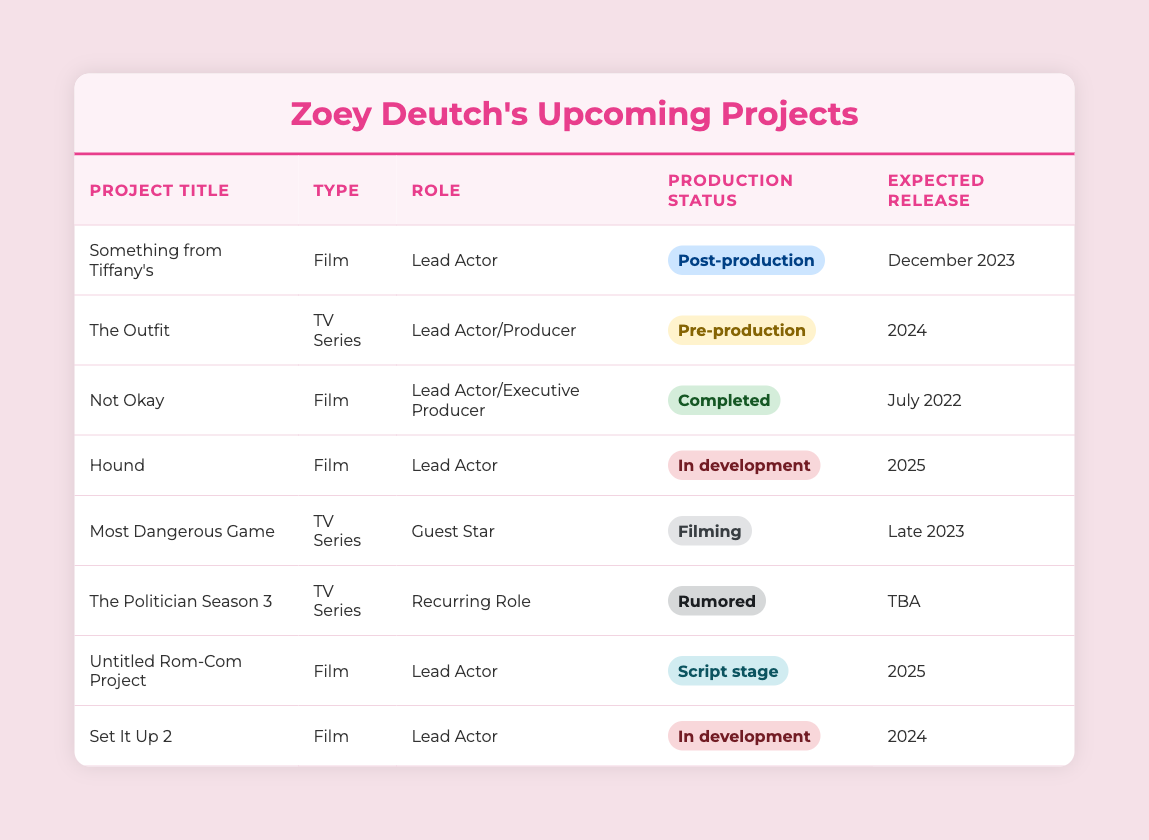What is the expected release date of "Something from Tiffany's"? The table lists the project "Something from Tiffany's" under the 'Expected Release' column, which shows "December 2023."
Answer: December 2023 How many projects are in development? The table highlights the projects "Hound" and "Set It Up 2" as being in the status of "In development." Thus, there are 2 projects in this category.
Answer: 2 Is "Not Okay" still under production? "Not Okay" is marked as "Completed" in the production status column, which means it is no longer being produced.
Answer: No What project has the status of post-production? Referring to the table, "Something from Tiffany's" is the only project with the status "Post-production."
Answer: Something from Tiffany's Which type of project has the latest expected release date? Looking at the expected release dates, "Something from Tiffany's" is scheduled for December 2023, and all other projects either have a later date or are unspecified. Therefore, this is the latest date.
Answer: Something from Tiffany's Are there more TV series projects than films upcoming from Zoey Deutch? There are four TV series (The Outfit, Most Dangerous Game, The Politician Season 3, and The Outfit) and four films (Something from Tiffany's, Not Okay, Hound, and Set It Up 2). Since they are equal, the answer is no.
Answer: No What is the total number of projects expected to release in 2025? Upon reviewing the table, the projects "Hound" and "Untitled Rom-Com Project" are expected to release in 2025. Therefore, adding them gives a total of 2 projects.
Answer: 2 Which project involves Zoey Deutch as an executive producer? The table shows that "Not Okay" is the project where Zoey Deutch holds the role of Executive Producer along with Lead Actor.
Answer: Not Okay Is "The Politician Season 3" confirmed to be in production? The status of "The Politician Season 3" is listed as "Rumored," indicating it is not confirmed.
Answer: No 